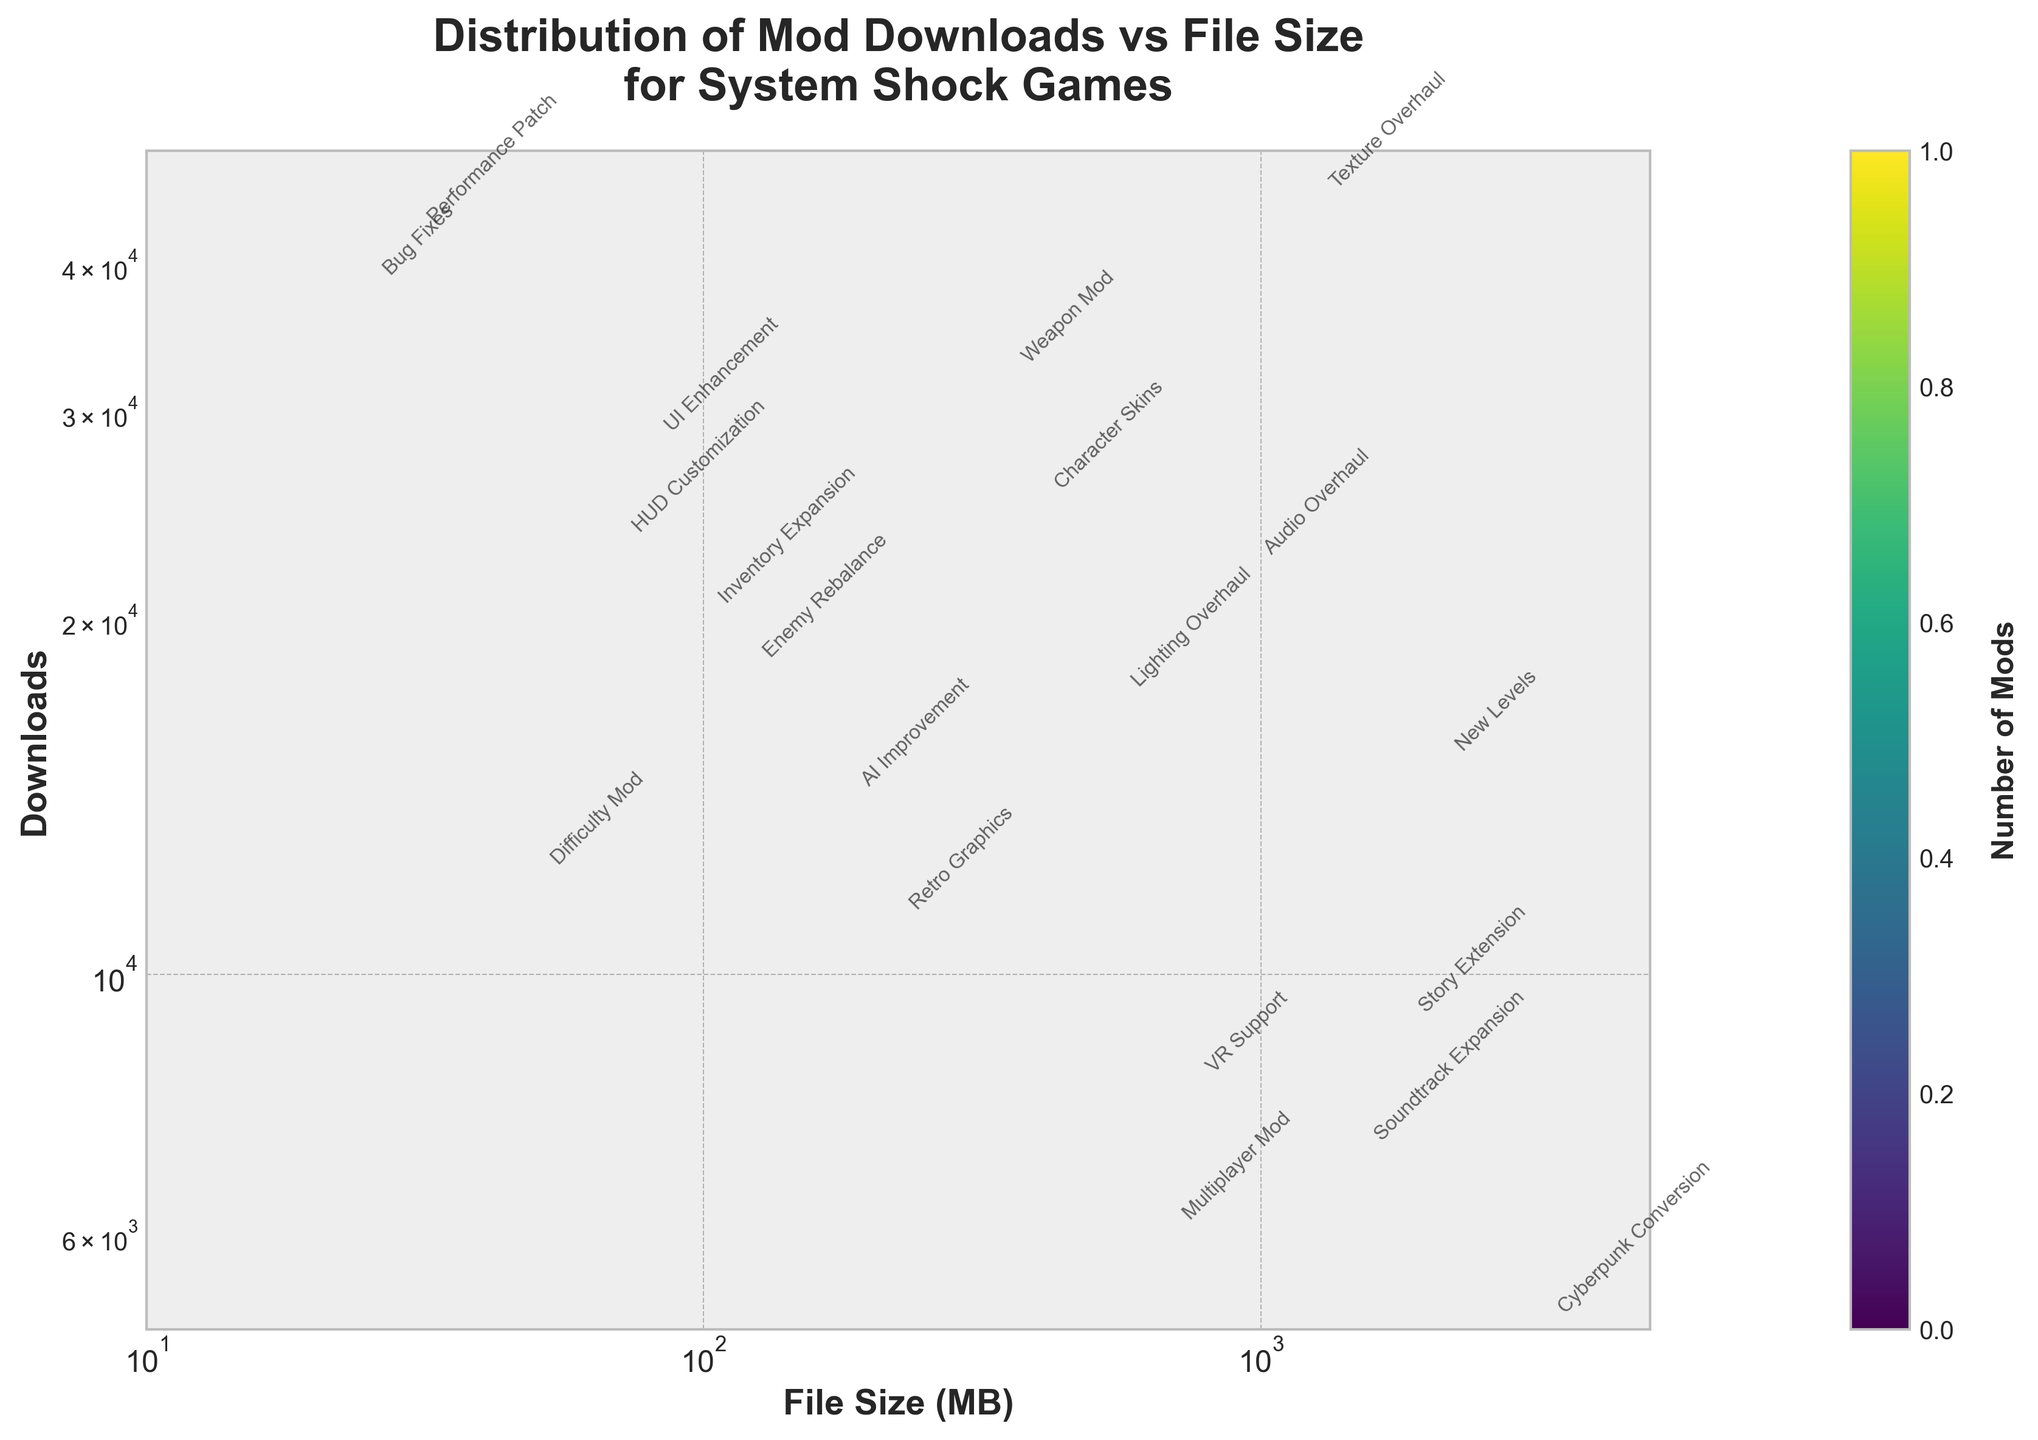What is the title of the plot? The title is prominently displayed at the top of the figure.
Answer: Distribution of Mod Downloads vs File Size for System Shock Games What are the units of the x-axis? The label under the x-axis provides the information on the units used.
Answer: MB (Megabytes) Which mod category appears to have the highest number of downloads? Looking closely at the labels and the data points, Performance_Patch has the highest position on the y-axis.
Answer: Performance Patch Are there more mods with file sizes above or below 1 GB? Visual inspection of the x-axis on a logarithmic scale shows more data points clustered below the 1 GB mark compared to above it.
Answer: Below 1 GB What mod category has around 18000 downloads with a file size under 200 MB? Identify the point annotated with "Enemy_Rebalance" by matching its approximate y-axis value and x-axis value.
Answer: Enemy Rebalance Which mod category has a file size around 1500 MB and around 7000 downloads? Look at all the annotations and find the one with these approximate coordinates, which is "Soundtrack_Expansion".
Answer: Soundtrack Expansion Between AI Improvement and Character Skins mods, which one has more downloads? Compare their relative positions on the y-axis. Character Skins is higher.
Answer: Character Skins What is the approximate file size range for mods with downloads above 20000? Examine the spread of points above the 20000 mark on the y-axis; they range from approximately 25 MB to 1250 MB.
Answer: 25 MB to 1250 MB Which mod category has the smallest file size and what are its downloads? The point labeled "Bug_Fixes" has the smallest x-axis value with the corresponding y-axis value indicated.
Answer: Bug Fixes, 38000 Downloads What is the relationship between New Levels and Story Extension mods in terms of file size and downloads? New Levels has a larger file size (2100 MB) and more downloads (15000) compared to Story Extension (1800 MB, 9000 downloads).
Answer: New Levels has larger file size and more downloads 